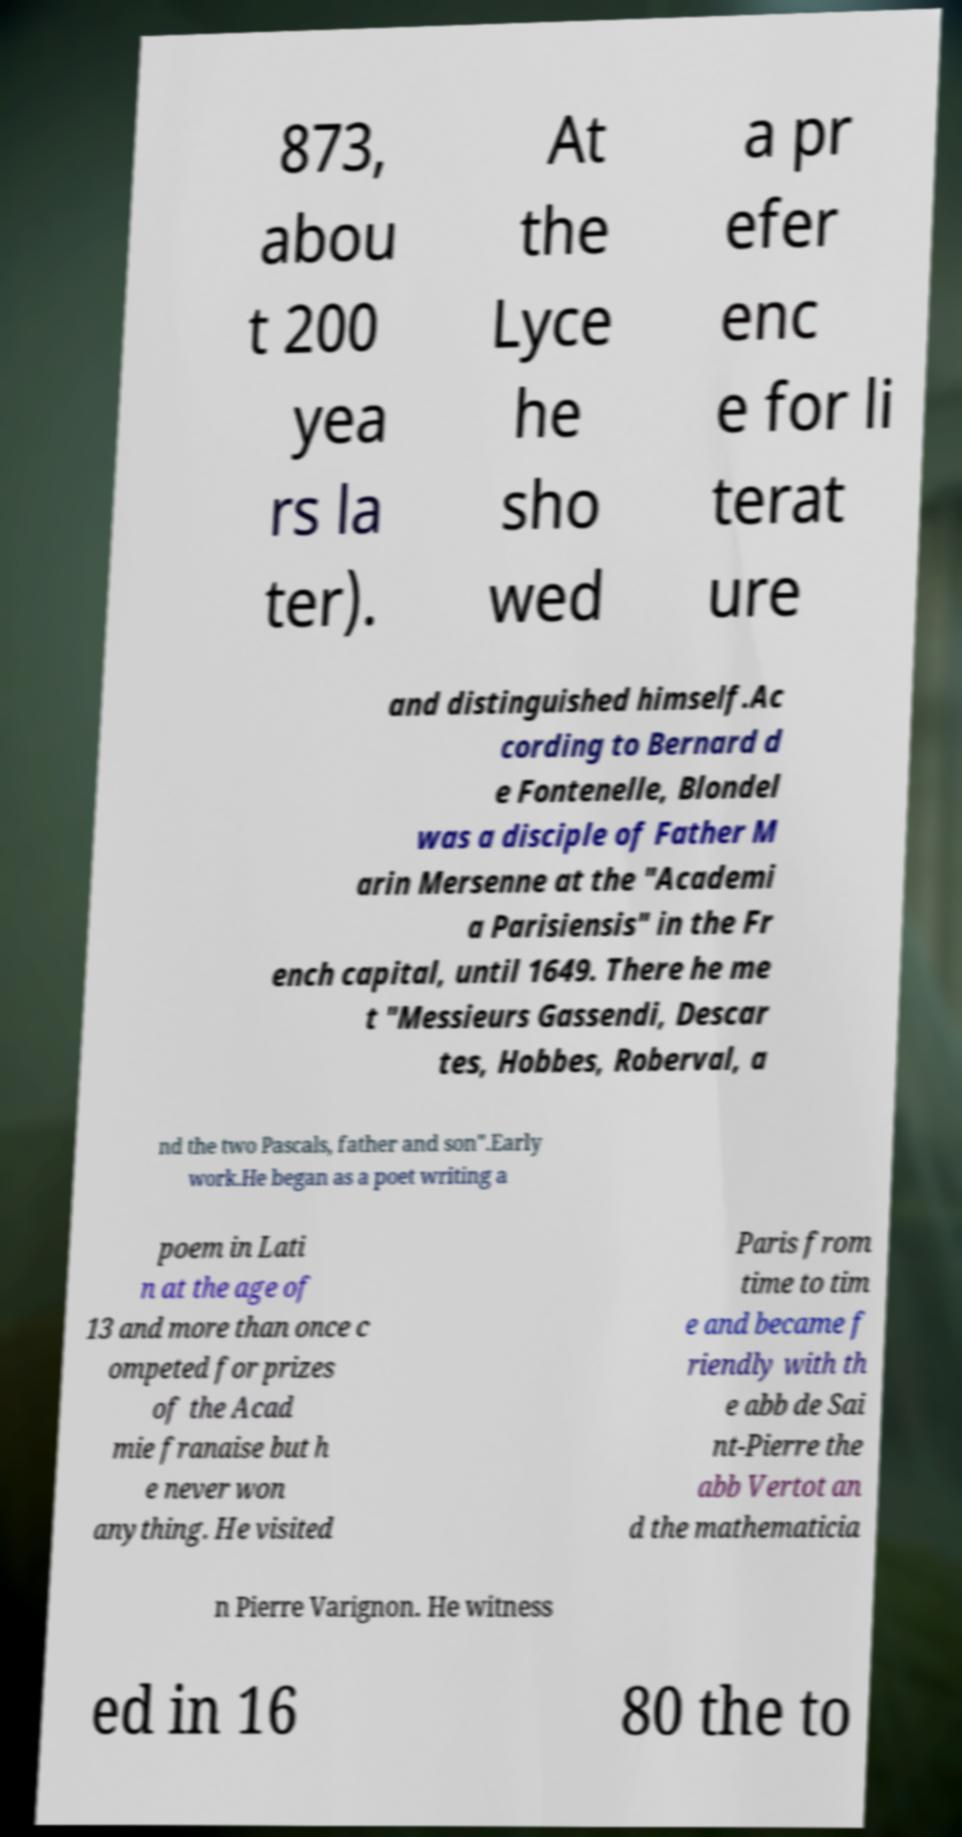Please identify and transcribe the text found in this image. 873, abou t 200 yea rs la ter). At the Lyce he sho wed a pr efer enc e for li terat ure and distinguished himself.Ac cording to Bernard d e Fontenelle, Blondel was a disciple of Father M arin Mersenne at the "Academi a Parisiensis" in the Fr ench capital, until 1649. There he me t "Messieurs Gassendi, Descar tes, Hobbes, Roberval, a nd the two Pascals, father and son".Early work.He began as a poet writing a poem in Lati n at the age of 13 and more than once c ompeted for prizes of the Acad mie franaise but h e never won anything. He visited Paris from time to tim e and became f riendly with th e abb de Sai nt-Pierre the abb Vertot an d the mathematicia n Pierre Varignon. He witness ed in 16 80 the to 